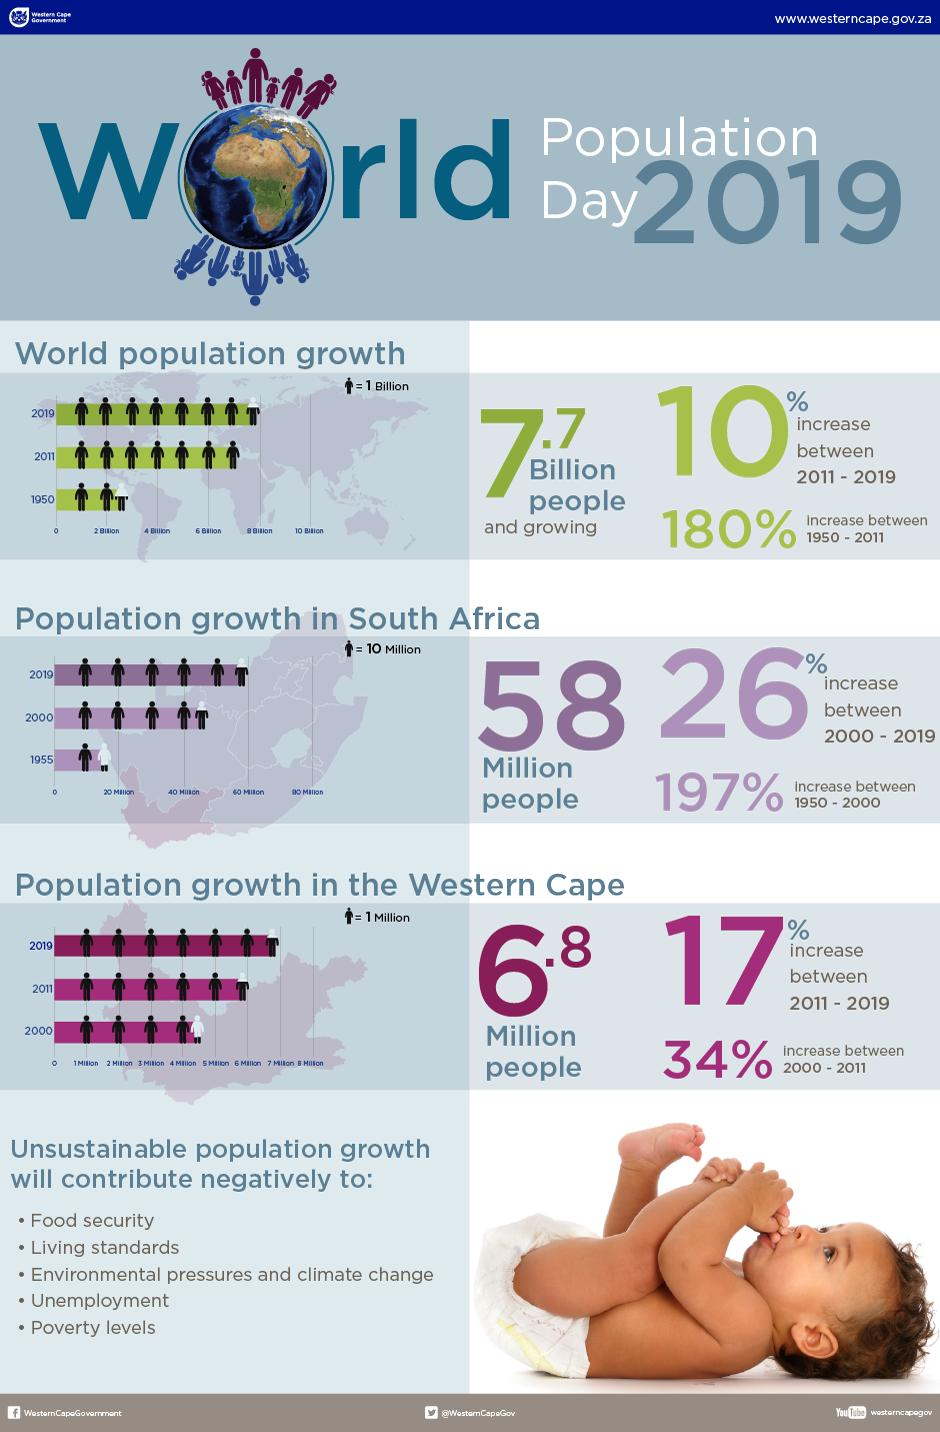Indicate a few pertinent items in this graphic. According to the data, the population growth in South Africa since 2000 was 26%. In this text, there are five negative references to unsustainable population growth. Unsustainable population growth is a significant factor that can negatively impact food security, living standards, and poverty levels, thereby threatening the well-being of individuals and communities. The world population has experienced a significant increase in growth since 1950, with a percentage increase of 180%. The population in the Western Cape has increased by 34% since 1950. 